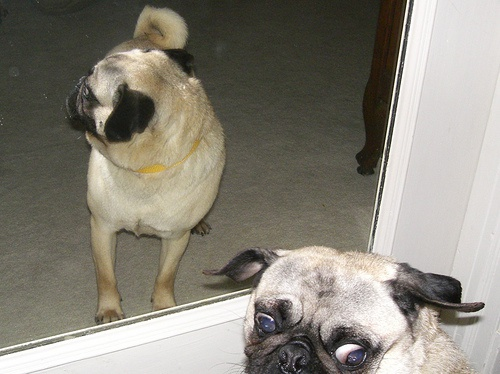Describe the objects in this image and their specific colors. I can see dog in black, tan, and gray tones and dog in black, lightgray, gray, and darkgray tones in this image. 